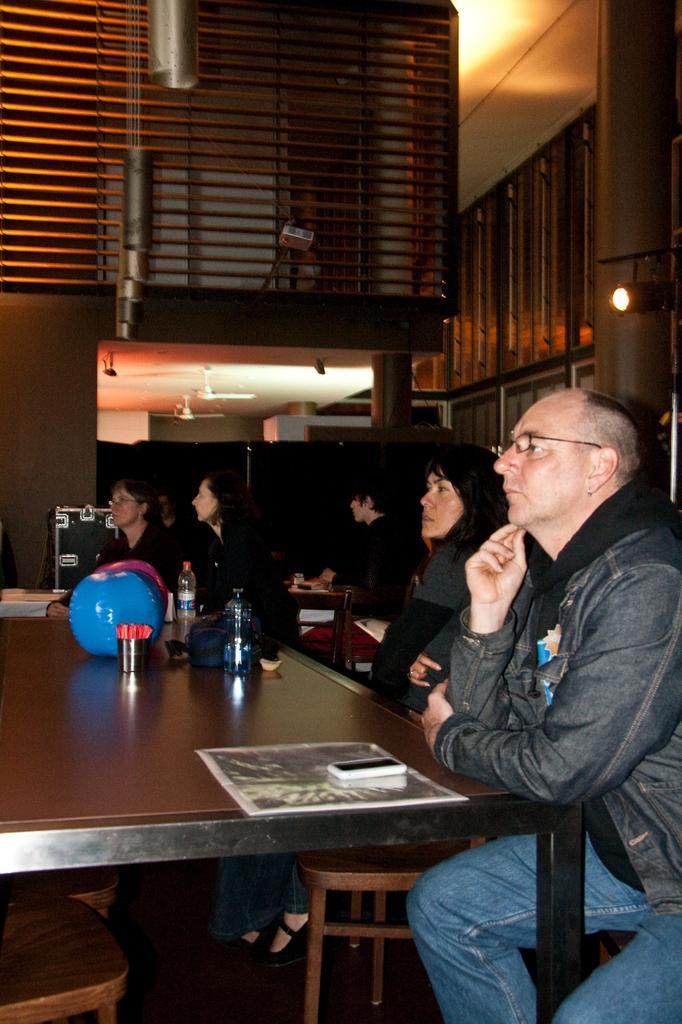In one or two sentences, can you explain what this image depicts? In this image I can see few people are sitting on chairs. Here on this table I can see a phone and few bottles. 